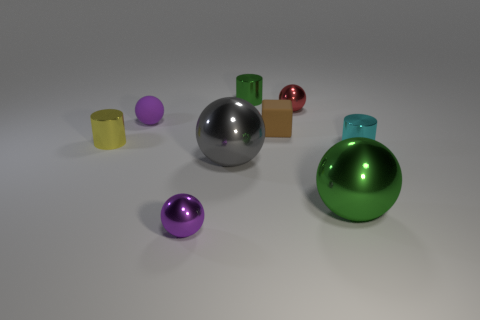Subtract all tiny balls. How many balls are left? 2 Subtract all gray cylinders. How many purple spheres are left? 2 Subtract all purple balls. How many balls are left? 3 Subtract 1 cylinders. How many cylinders are left? 2 Add 1 small purple metal objects. How many objects exist? 10 Subtract all spheres. How many objects are left? 4 Subtract all brown spheres. Subtract all brown blocks. How many spheres are left? 5 Subtract all metallic cylinders. Subtract all purple objects. How many objects are left? 4 Add 2 tiny rubber objects. How many tiny rubber objects are left? 4 Add 4 red balls. How many red balls exist? 5 